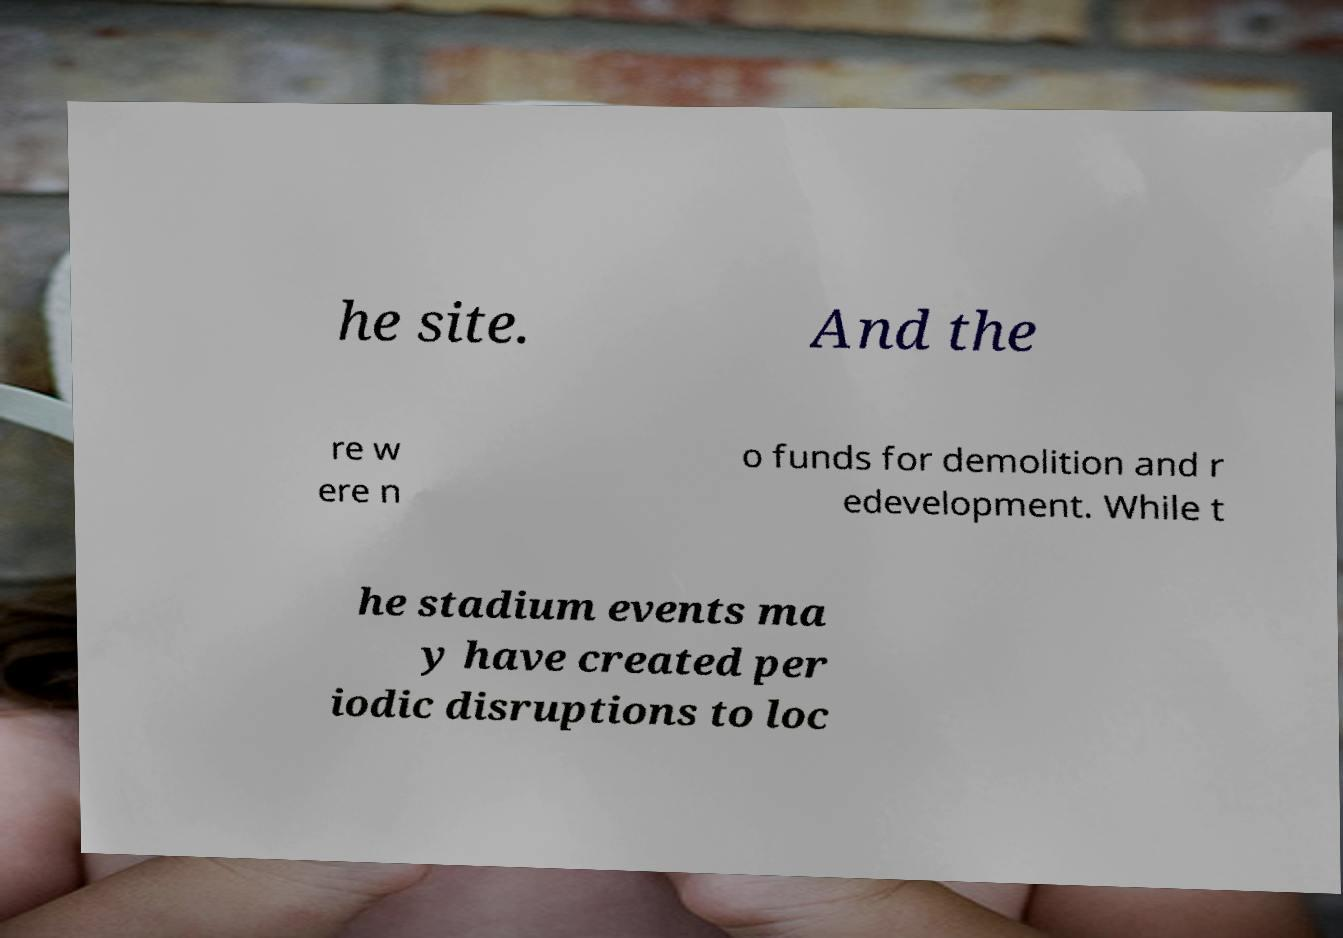Could you extract and type out the text from this image? he site. And the re w ere n o funds for demolition and r edevelopment. While t he stadium events ma y have created per iodic disruptions to loc 